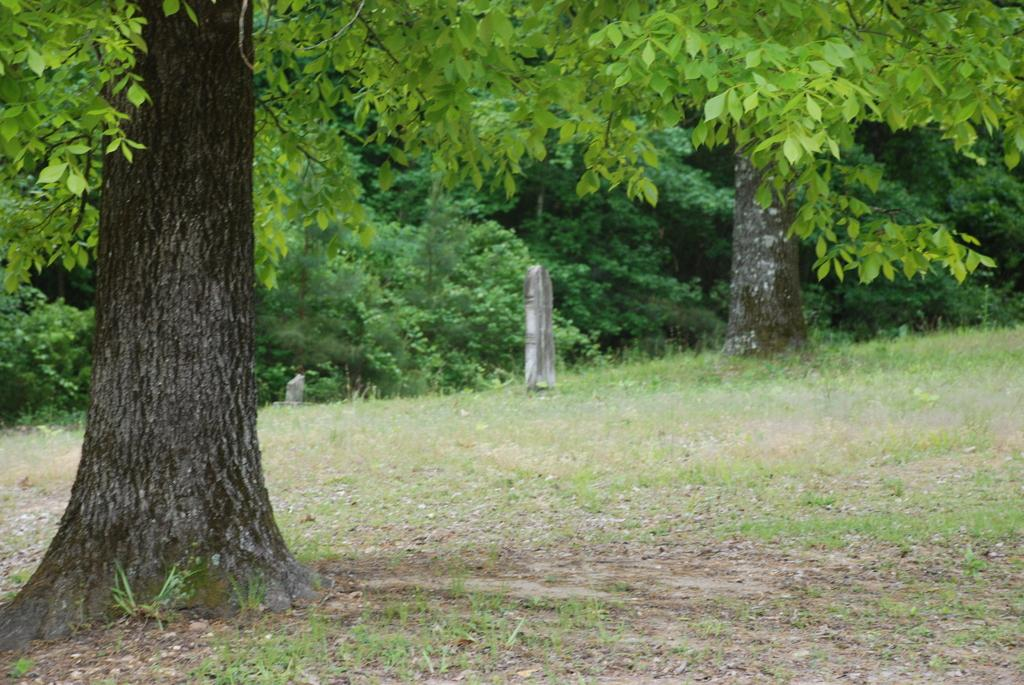Where was the image taken? The image was taken outdoors. What type of ground is visible in the image? There is a ground with grass in the image. What can be seen in the background of the image? There are many trees and plants with green leaves in the background of the image. What type of crown is worn by the beast in the image? There is no beast or crown present in the image. 